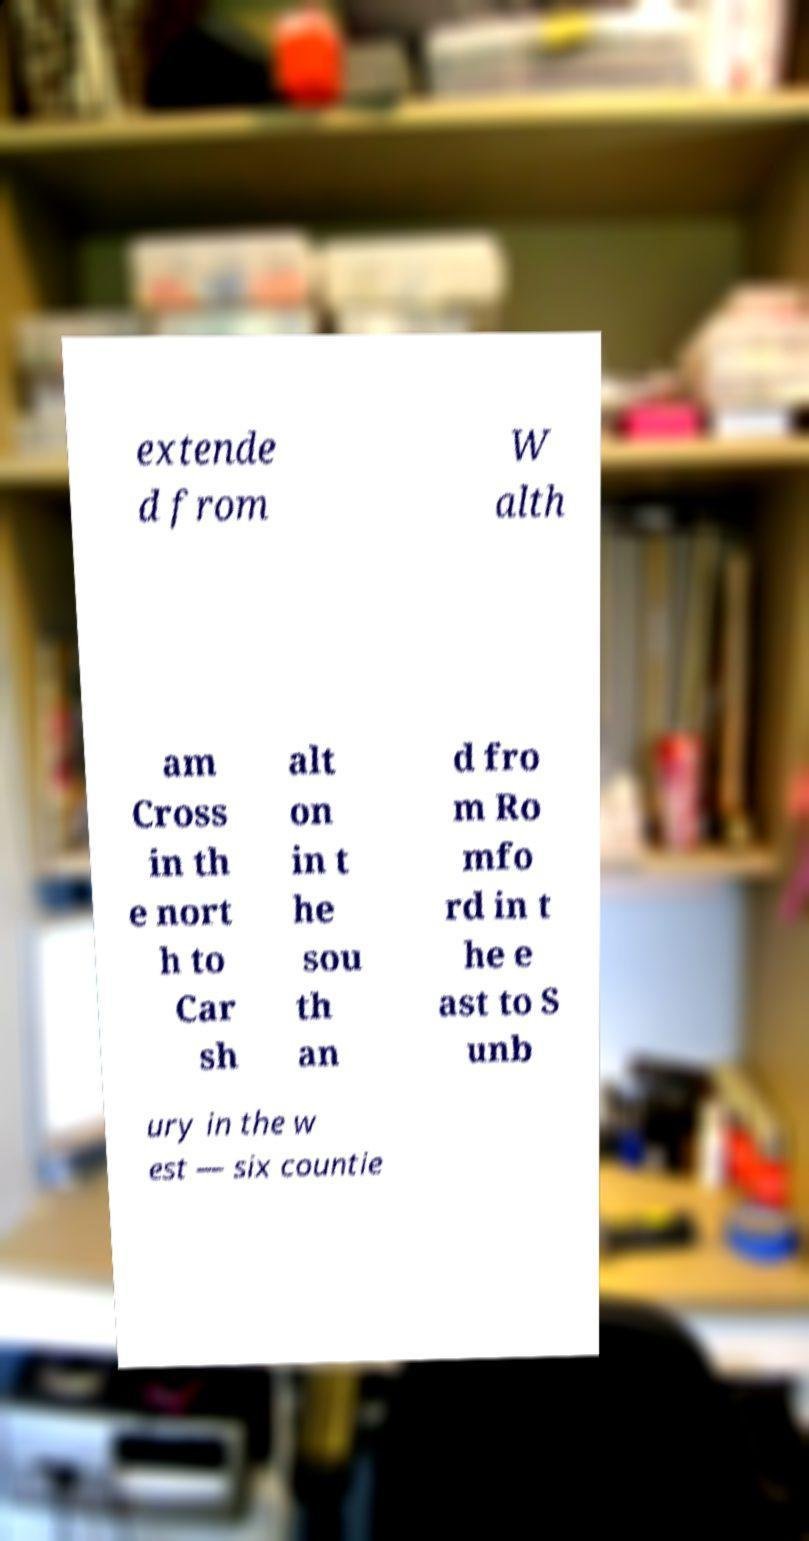What messages or text are displayed in this image? I need them in a readable, typed format. extende d from W alth am Cross in th e nort h to Car sh alt on in t he sou th an d fro m Ro mfo rd in t he e ast to S unb ury in the w est — six countie 